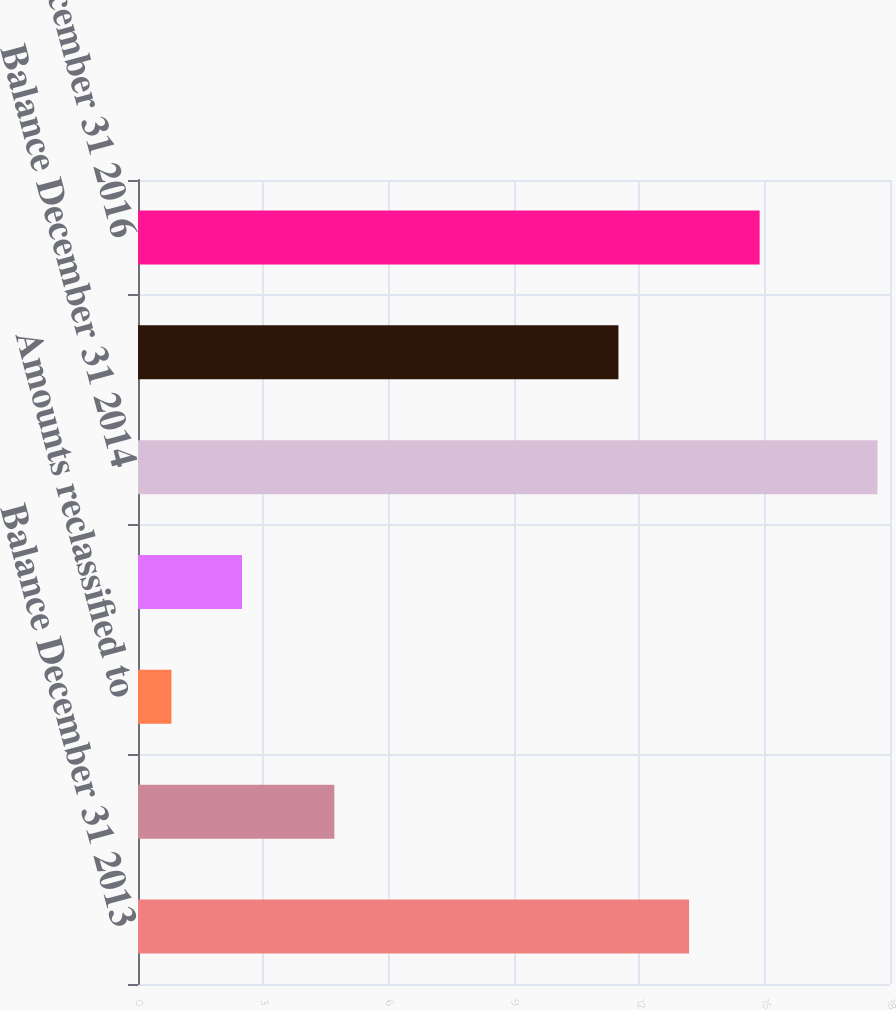Convert chart to OTSL. <chart><loc_0><loc_0><loc_500><loc_500><bar_chart><fcel>Balance December 31 2013<fcel>Other comprehensive income<fcel>Amounts reclassified to<fcel>Tax benefit (expense)<fcel>Balance December 31 2014<fcel>Balance December 31 2015<fcel>Balance December 31 2016<nl><fcel>13.19<fcel>4.7<fcel>0.8<fcel>2.49<fcel>17.7<fcel>11.5<fcel>14.88<nl></chart> 